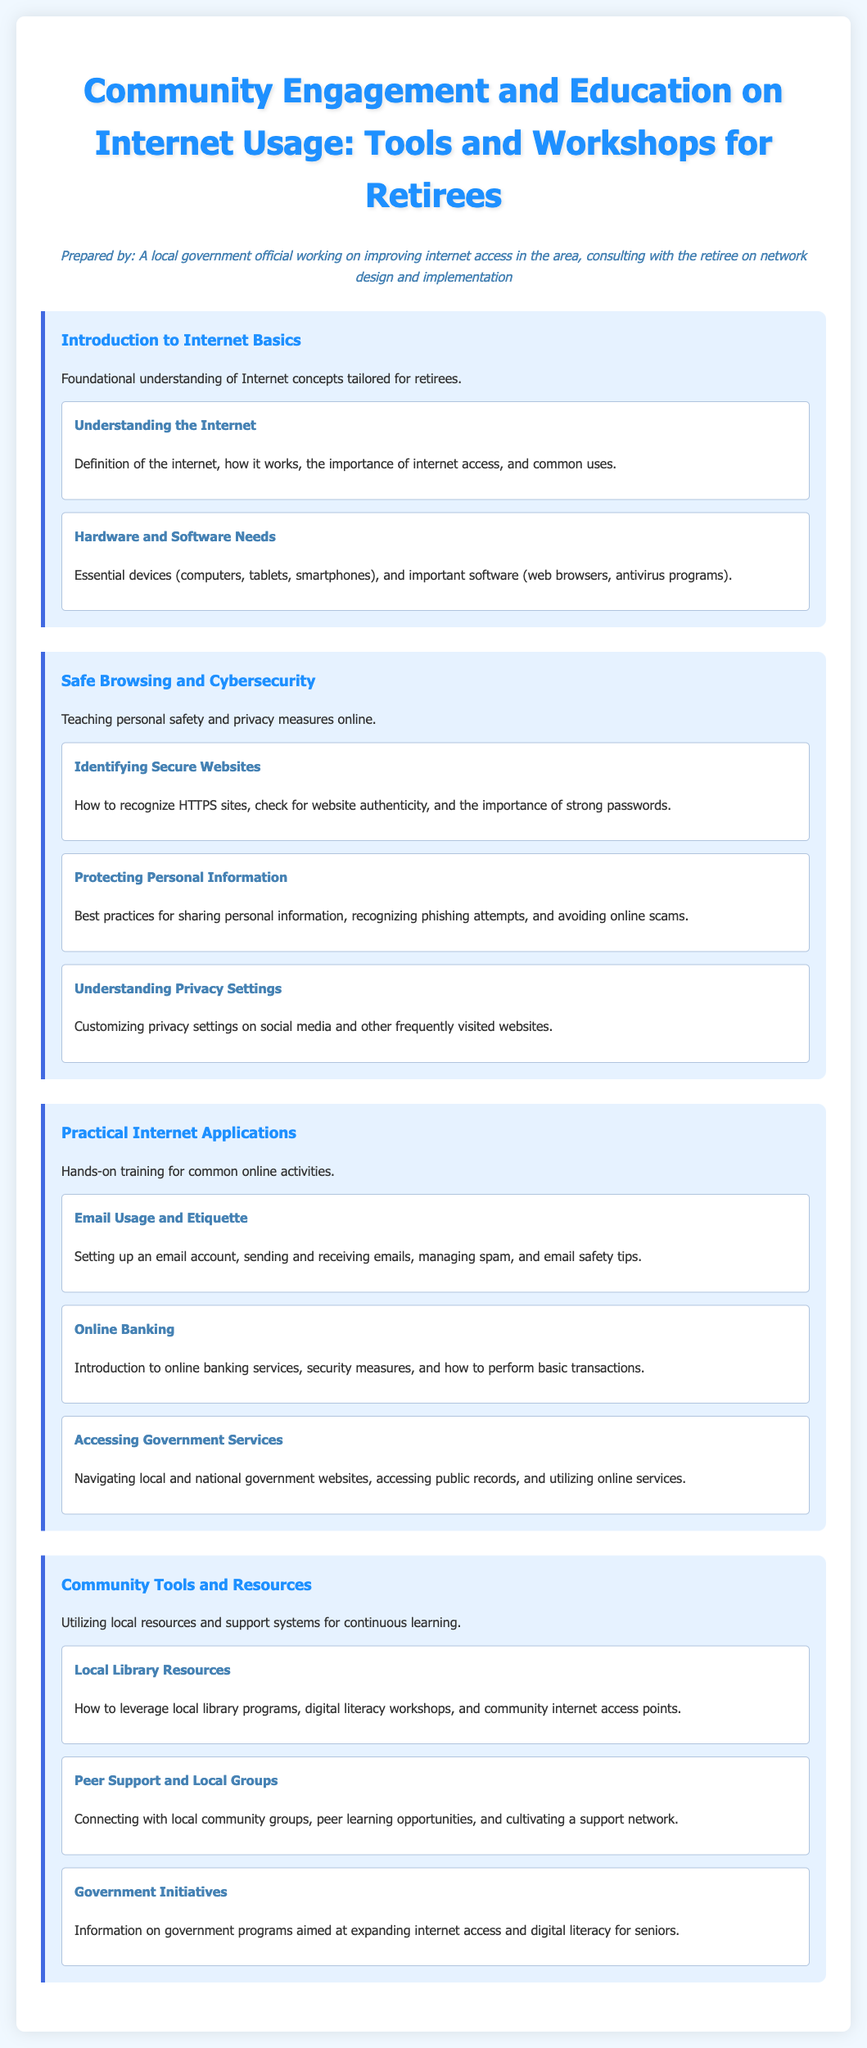what is the title of the syllabus? The title of the syllabus is prominently displayed at the top of the document.
Answer: Community Engagement and Education on Internet Usage: Tools and Workshops for Retirees how many modules are included in the syllabus? The syllabus has four distinct modules outlined in the document.
Answer: 4 what is the focus of the first module? The first module introduces foundational understanding and basic concepts tailored for retirees.
Answer: Introduction to Internet Basics which topic covers email management? The topic about email management is part of practical training for online activities.
Answer: Email Usage and Etiquette what is one of the best practices mentioned for protecting personal information? The document specifies various safety measures for online privacy amidst potential online threats.
Answer: Recognizing phishing attempts name a resource mentioned for continuous learning. A specific local resource outlined in the syllabus is aimed at enhancing digital literacy in the community.
Answer: Local Library Resources who prepared the syllabus? An individual affiliated with local government focused on community internet access designed the syllabus.
Answer: A local government official what type of activities does the last module emphasize? The last module is centered around utilizing community resources and looking for support systems.
Answer: Community Tools and Resources 